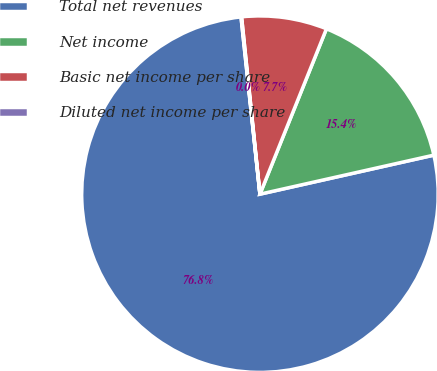<chart> <loc_0><loc_0><loc_500><loc_500><pie_chart><fcel>Total net revenues<fcel>Net income<fcel>Basic net income per share<fcel>Diluted net income per share<nl><fcel>76.82%<fcel>15.4%<fcel>7.73%<fcel>0.05%<nl></chart> 